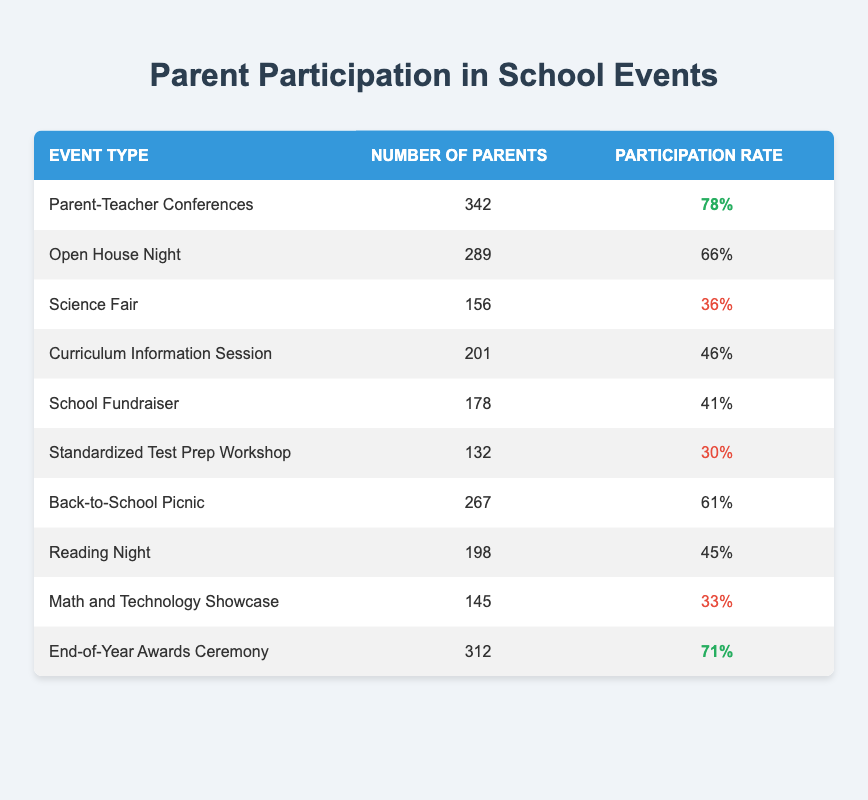What is the participation rate for the Science Fair? The Science Fair event shows a participation rate of 36% based on the corresponding row in the table.
Answer: 36% Which event had the highest number of parents attending? By reviewing the "Number of Parents" column, the event with the highest attendance is the Parent-Teacher Conferences with 342 parents.
Answer: 342 Is the participation rate for the Standardized Test Prep Workshop higher than the Math and Technology Showcase? The participation rate for the Standardized Test Prep Workshop is 30%, while for the Math and Technology Showcase, it is 33%. Thus, 30% is not higher than 33%.
Answer: No What is the average participation rate of events associated with a low participation category (30%-41%)? The events classified as low participation are Standardized Test Prep Workshop (30%), Math and Technology Showcase (33%), School Fundraiser (41%), and Science Fair (36%). To find the average, sum these percentages (30 + 33 + 41 + 36) = 140, then divide by 4 (as there are 4 events), resulting in an average participation rate of 35%.
Answer: 35% How many events have a participation rate of 60% or above? Reviewing the table, we find that there are four events with a rate of 60% or higher: Parent-Teacher Conferences (78%), Open House Night (66%), Back-to-School Picnic (61%), and End-of-Year Awards Ceremony (71%). Therefore, the total is 4 events.
Answer: 4 What is the difference in the number of parents between the Back-to-School Picnic and the Curriculum Information Session? The Back-to-School Picnic had 267 parents, while the Curriculum Information Session had 201 parents. Subtracting 201 from 267 gives a difference of 66 parents attending more at the picnic.
Answer: 66 How does the participation rate of the End-of-Year Awards Ceremony compare to that of the Reading Night? The participation rate for the End-of-Year Awards Ceremony is 71%, while for Reading Night, it is 45%. Since 71% is greater than 45%, we conclude that the End-of-Year Awards Ceremony has a higher participation rate.
Answer: Yes Which event or events had a participation rate below 40%? Looking at the table, the events with a participation rate below 40% are the Standardized Test Prep Workshop (30%), Math and Technology Showcase (33%), and Science Fair (36%). Therefore, there are three such events.
Answer: 3 